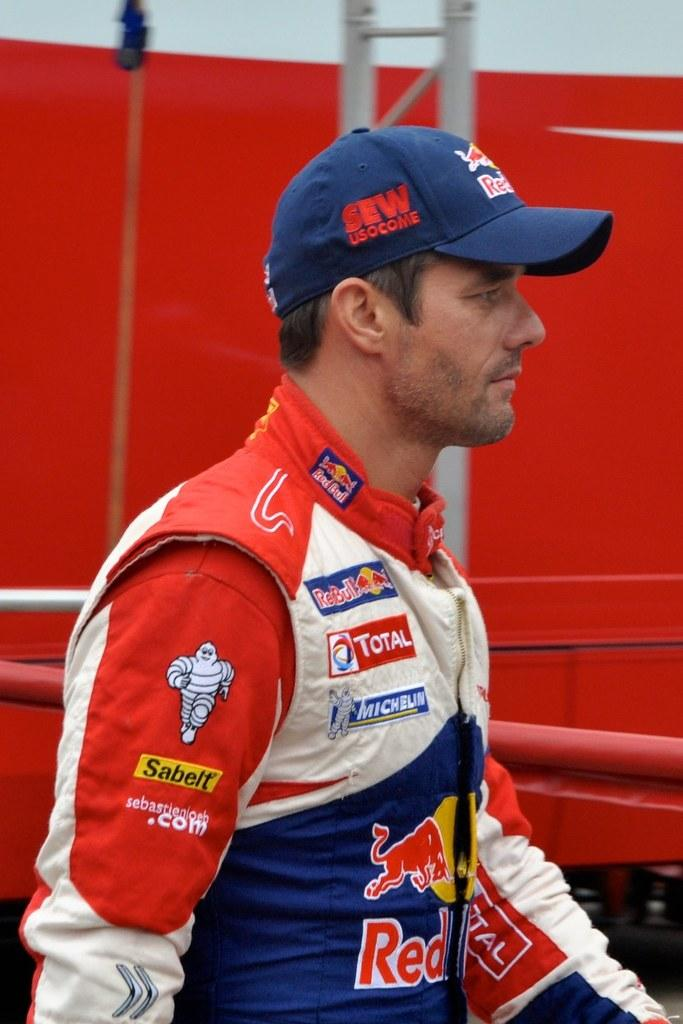Provide a one-sentence caption for the provided image. a sleeve that has the word sabelt on it. 